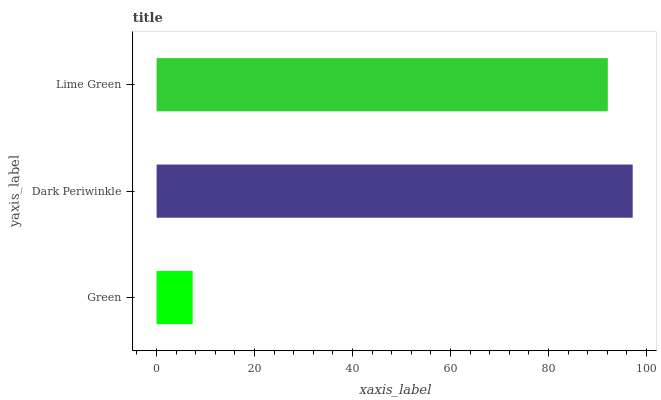Is Green the minimum?
Answer yes or no. Yes. Is Dark Periwinkle the maximum?
Answer yes or no. Yes. Is Lime Green the minimum?
Answer yes or no. No. Is Lime Green the maximum?
Answer yes or no. No. Is Dark Periwinkle greater than Lime Green?
Answer yes or no. Yes. Is Lime Green less than Dark Periwinkle?
Answer yes or no. Yes. Is Lime Green greater than Dark Periwinkle?
Answer yes or no. No. Is Dark Periwinkle less than Lime Green?
Answer yes or no. No. Is Lime Green the high median?
Answer yes or no. Yes. Is Lime Green the low median?
Answer yes or no. Yes. Is Green the high median?
Answer yes or no. No. Is Dark Periwinkle the low median?
Answer yes or no. No. 